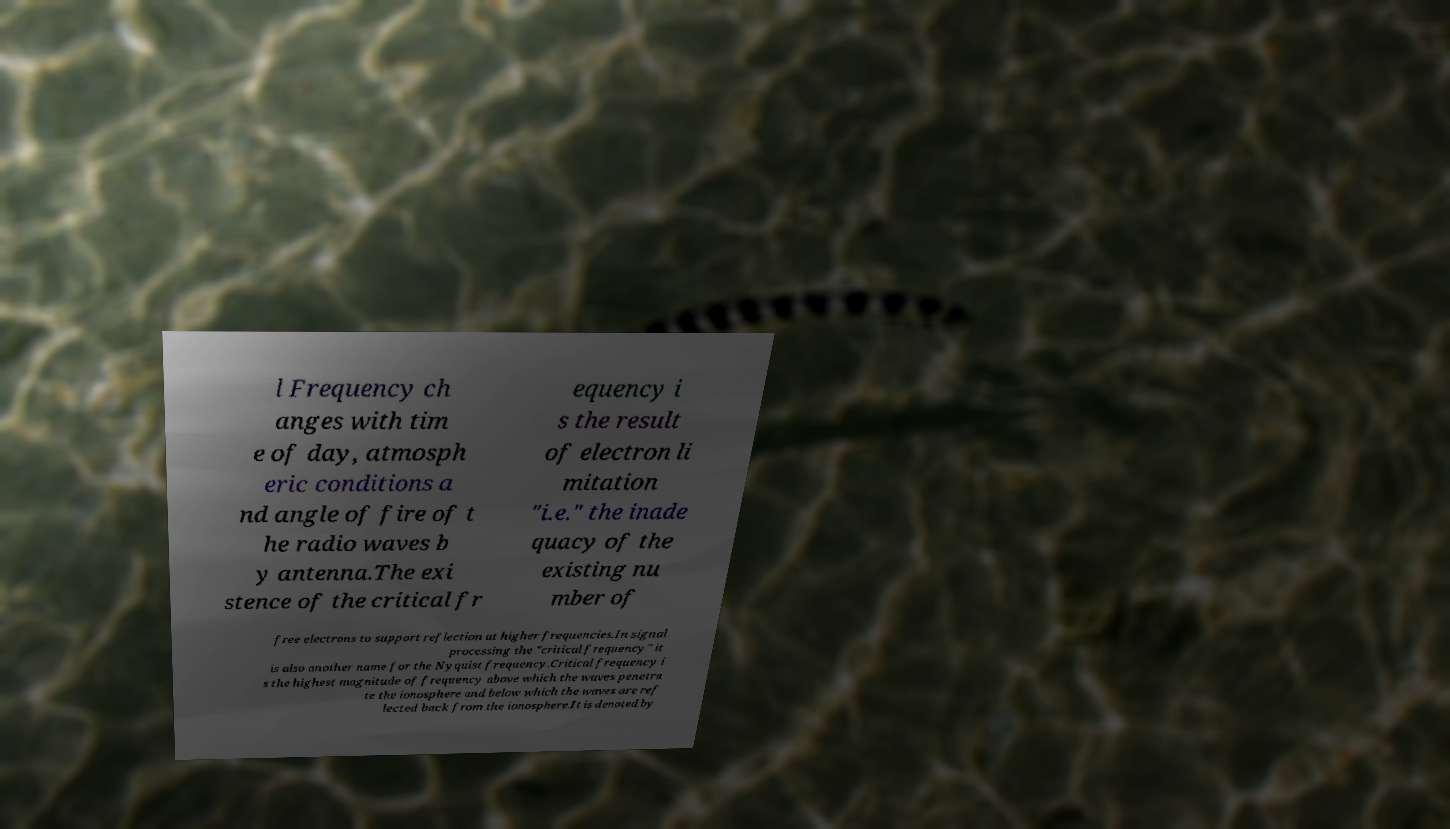What messages or text are displayed in this image? I need them in a readable, typed format. l Frequency ch anges with tim e of day, atmosph eric conditions a nd angle of fire of t he radio waves b y antenna.The exi stence of the critical fr equency i s the result of electron li mitation "i.e." the inade quacy of the existing nu mber of free electrons to support reflection at higher frequencies.In signal processing the "critical frequency" it is also another name for the Nyquist frequency.Critical frequency i s the highest magnitude of frequency above which the waves penetra te the ionosphere and below which the waves are ref lected back from the ionosphere.It is denoted by 